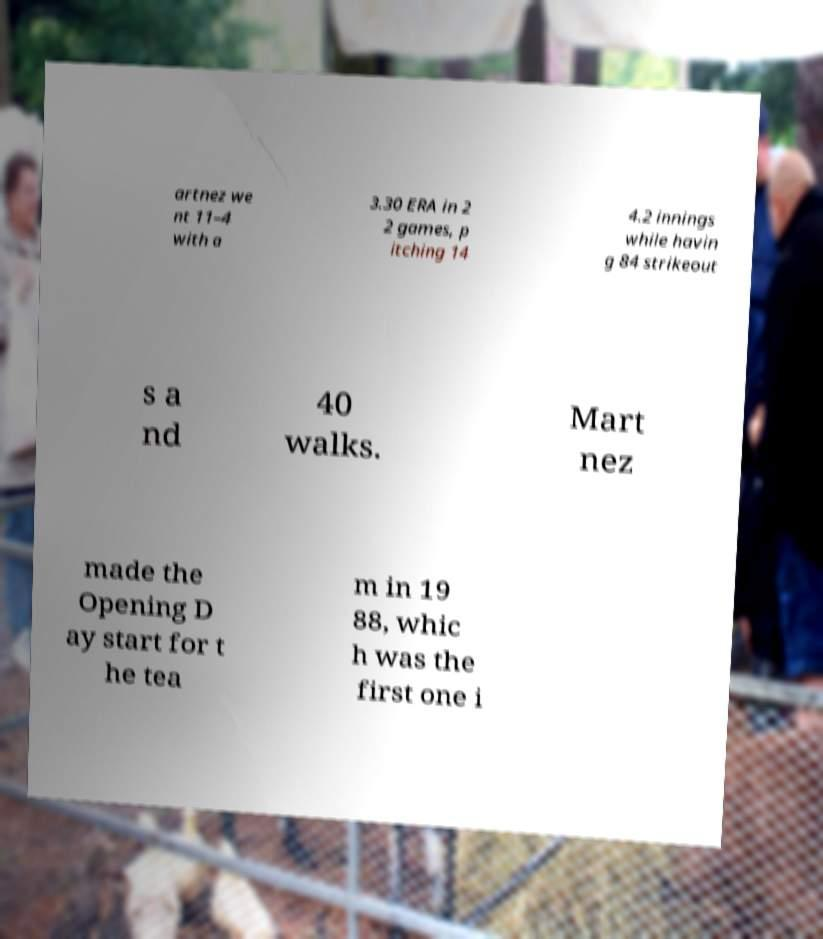Can you accurately transcribe the text from the provided image for me? artnez we nt 11–4 with a 3.30 ERA in 2 2 games, p itching 14 4.2 innings while havin g 84 strikeout s a nd 40 walks. Mart nez made the Opening D ay start for t he tea m in 19 88, whic h was the first one i 